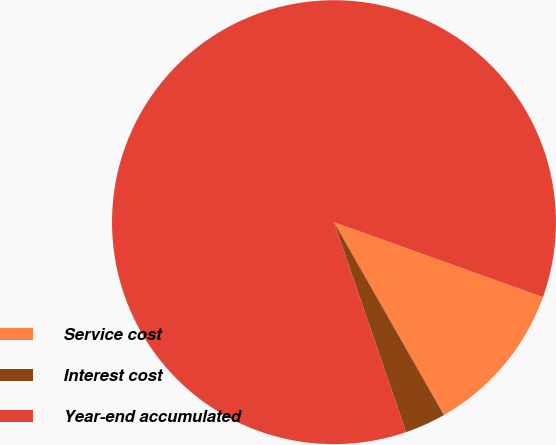Convert chart. <chart><loc_0><loc_0><loc_500><loc_500><pie_chart><fcel>Service cost<fcel>Interest cost<fcel>Year-end accumulated<nl><fcel>11.27%<fcel>2.99%<fcel>85.74%<nl></chart> 